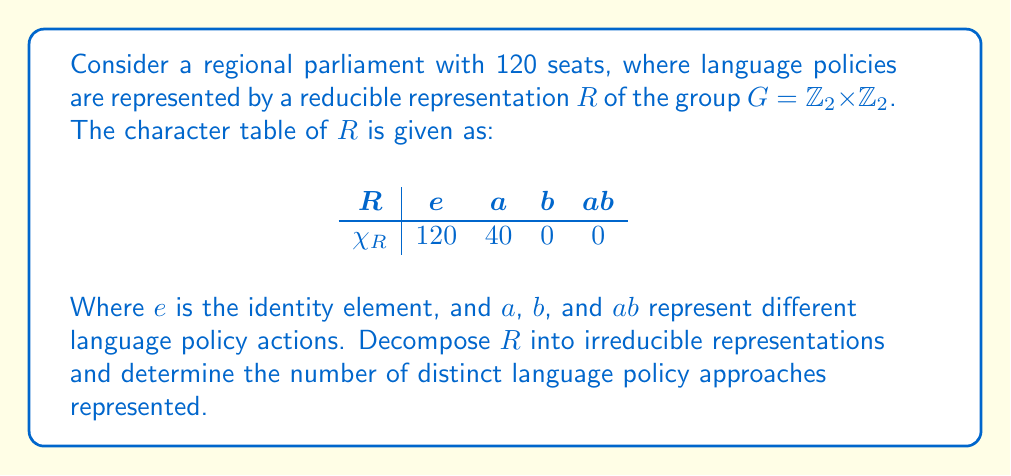Can you answer this question? 1) First, recall that for $G = \mathbb{Z}_2 \times \mathbb{Z}_2$, there are four irreducible representations, each of dimension 1. Let's call them $\rho_1, \rho_2, \rho_3, \rho_4$ with character tables:

$$
\begin{array}{c|cccc}
 & e & a & b & ab \\
\hline
\rho_1 & 1 & 1 & 1 & 1 \\
\rho_2 & 1 & 1 & -1 & -1 \\
\rho_3 & 1 & -1 & 1 & -1 \\
\rho_4 & 1 & -1 & -1 & 1
\end{array}
$$

2) To decompose $R$, we need to find the multiplicities of each irreducible representation. We use the formula:

$$ m_i = \frac{1}{|G|} \sum_{g \in G} \chi_R(g) \overline{\chi_{\rho_i}(g)} $$

3) Calculating for each $\rho_i$:

$$ m_1 = \frac{1}{4}(120 + 40 + 0 + 0) = 40 $$
$$ m_2 = \frac{1}{4}(120 + 40 + 0 + 0) = 40 $$
$$ m_3 = \frac{1}{4}(120 - 40 + 0 + 0) = 20 $$
$$ m_4 = \frac{1}{4}(120 - 40 + 0 + 0) = 20 $$

4) Therefore, the decomposition of $R$ is:

$$ R = 40\rho_1 \oplus 40\rho_2 \oplus 20\rho_3 \oplus 20\rho_4 $$

5) The number of distinct language policy approaches is equal to the number of non-zero multiplicities in this decomposition, which is 4.
Answer: 4 distinct approaches 